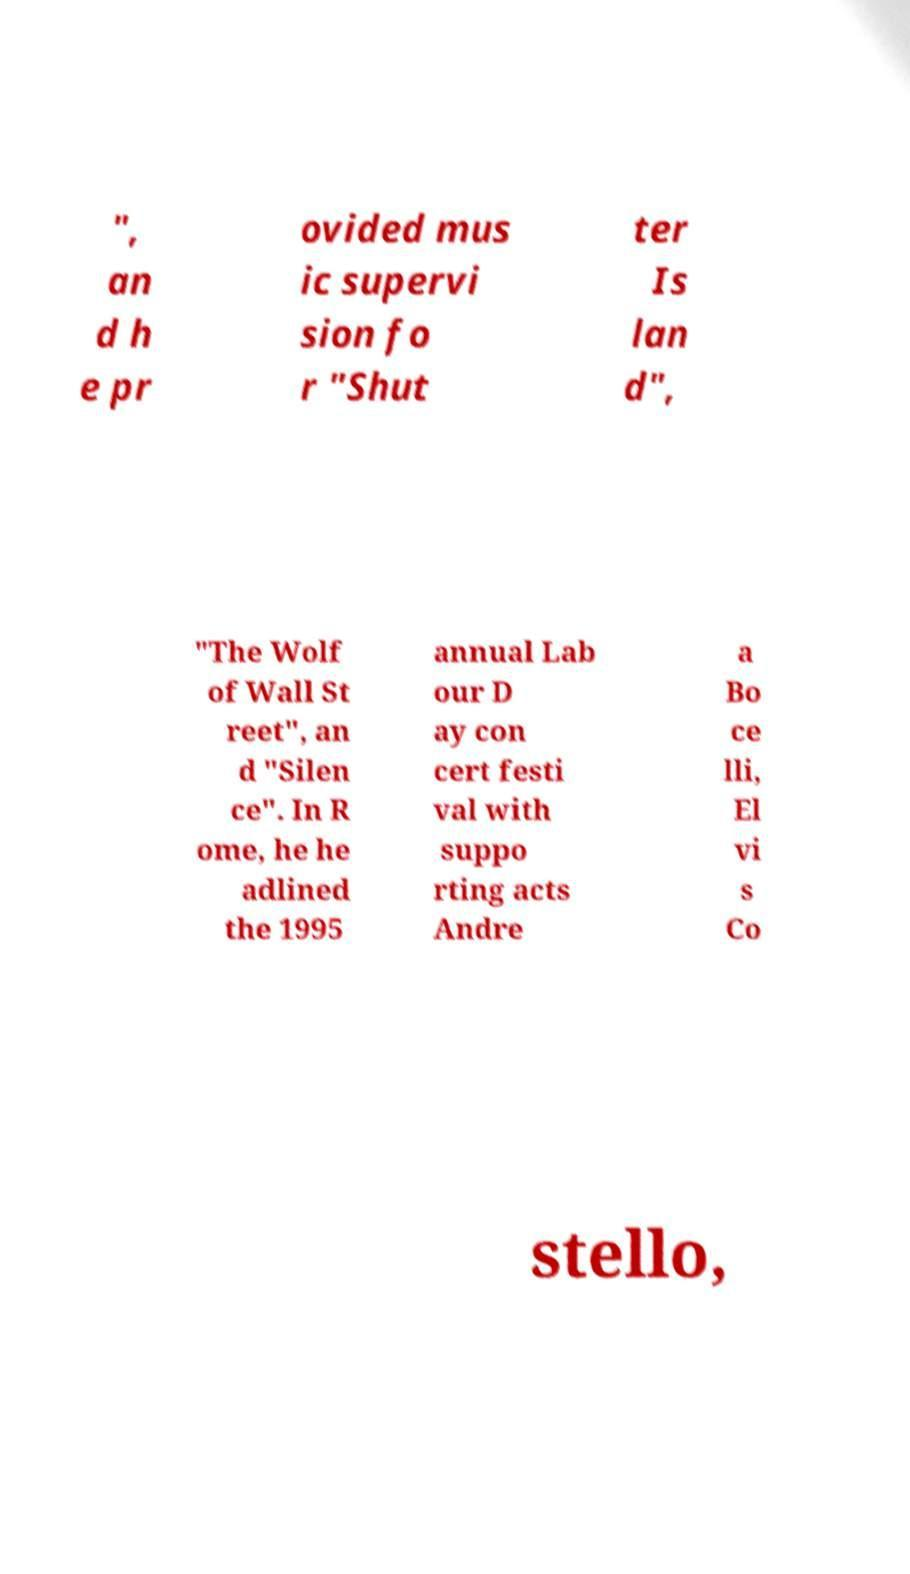For documentation purposes, I need the text within this image transcribed. Could you provide that? ", an d h e pr ovided mus ic supervi sion fo r "Shut ter Is lan d", "The Wolf of Wall St reet", an d "Silen ce". In R ome, he he adlined the 1995 annual Lab our D ay con cert festi val with suppo rting acts Andre a Bo ce lli, El vi s Co stello, 